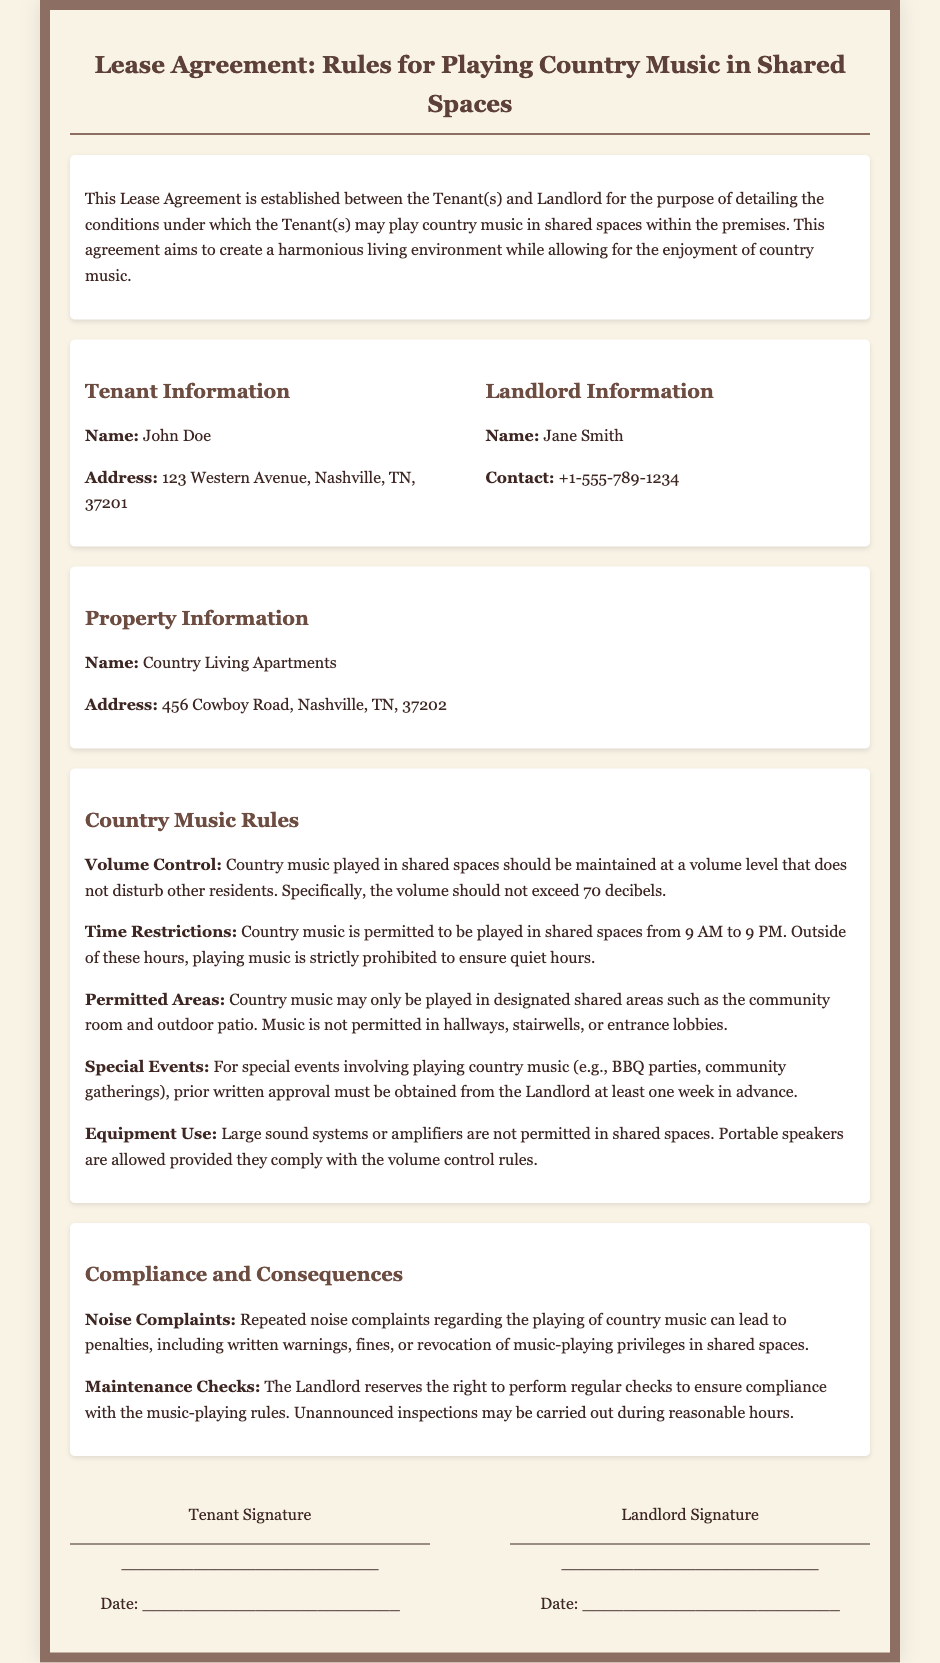What is the name of the tenant? The tenant's name is specified in the document as John Doe.
Answer: John Doe What is the property address? The document states the address of the property as 456 Cowboy Road, Nashville, TN, 37202.
Answer: 456 Cowboy Road, Nashville, TN, 37202 What is the maximum volume allowed for playing country music? The agreement stipulates that the volume should not exceed 70 decibels.
Answer: 70 decibels What time can country music be played? According to the rules, country music may be played from 9 AM to 9 PM.
Answer: 9 AM to 9 PM How much notice is required for special events? The document requires prior written approval at least one week in advance for special events involving music.
Answer: One week What are the consequences of repeated noise complaints? The document states that repeated complaints can lead to penalties such as written warnings or fines.
Answer: Warnings or fines Which areas are permitted for playing country music? The agreement specifies that country music is allowed in designated shared areas such as the community room and outdoor patio.
Answer: Community room and outdoor patio What is prohibited regarding the equipment used for playing music? The document indicates that large sound systems or amplifiers are not permitted in shared spaces.
Answer: Large sound systems or amplifiers Who is the landlord? The landlord's name given in the document is Jane Smith.
Answer: Jane Smith 